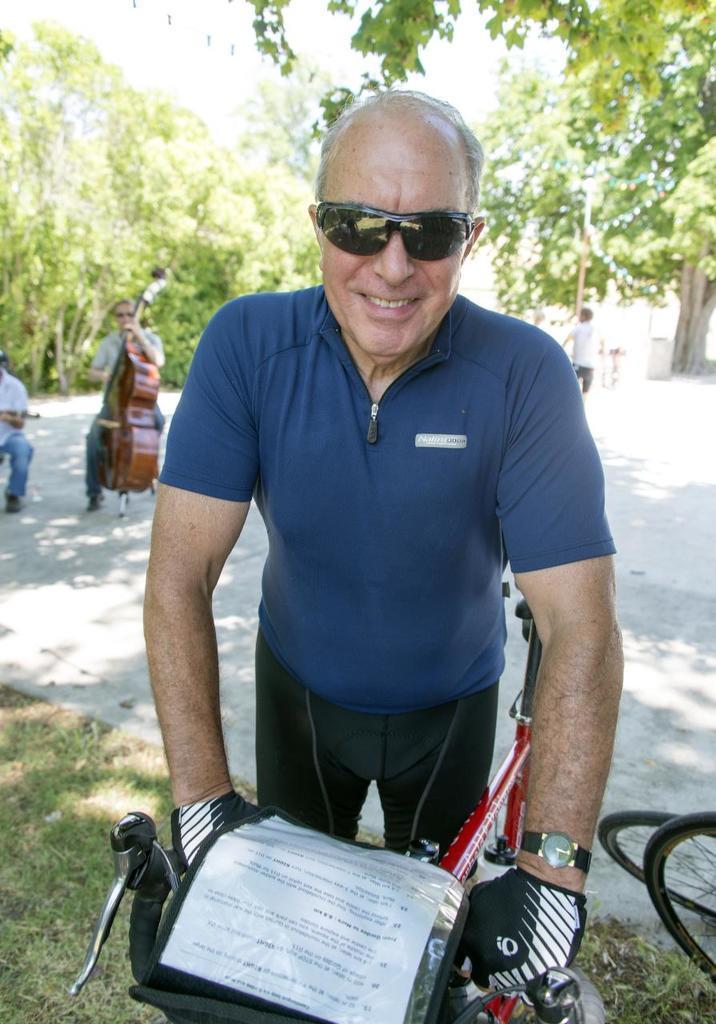Can you describe this image briefly? In this image we can see group of people standing on the ground. One person wearing goggles and t shirt is holding a bicycle with his hands. In the background we can see a person holding a guitar in his hand and group of trees and sky. 